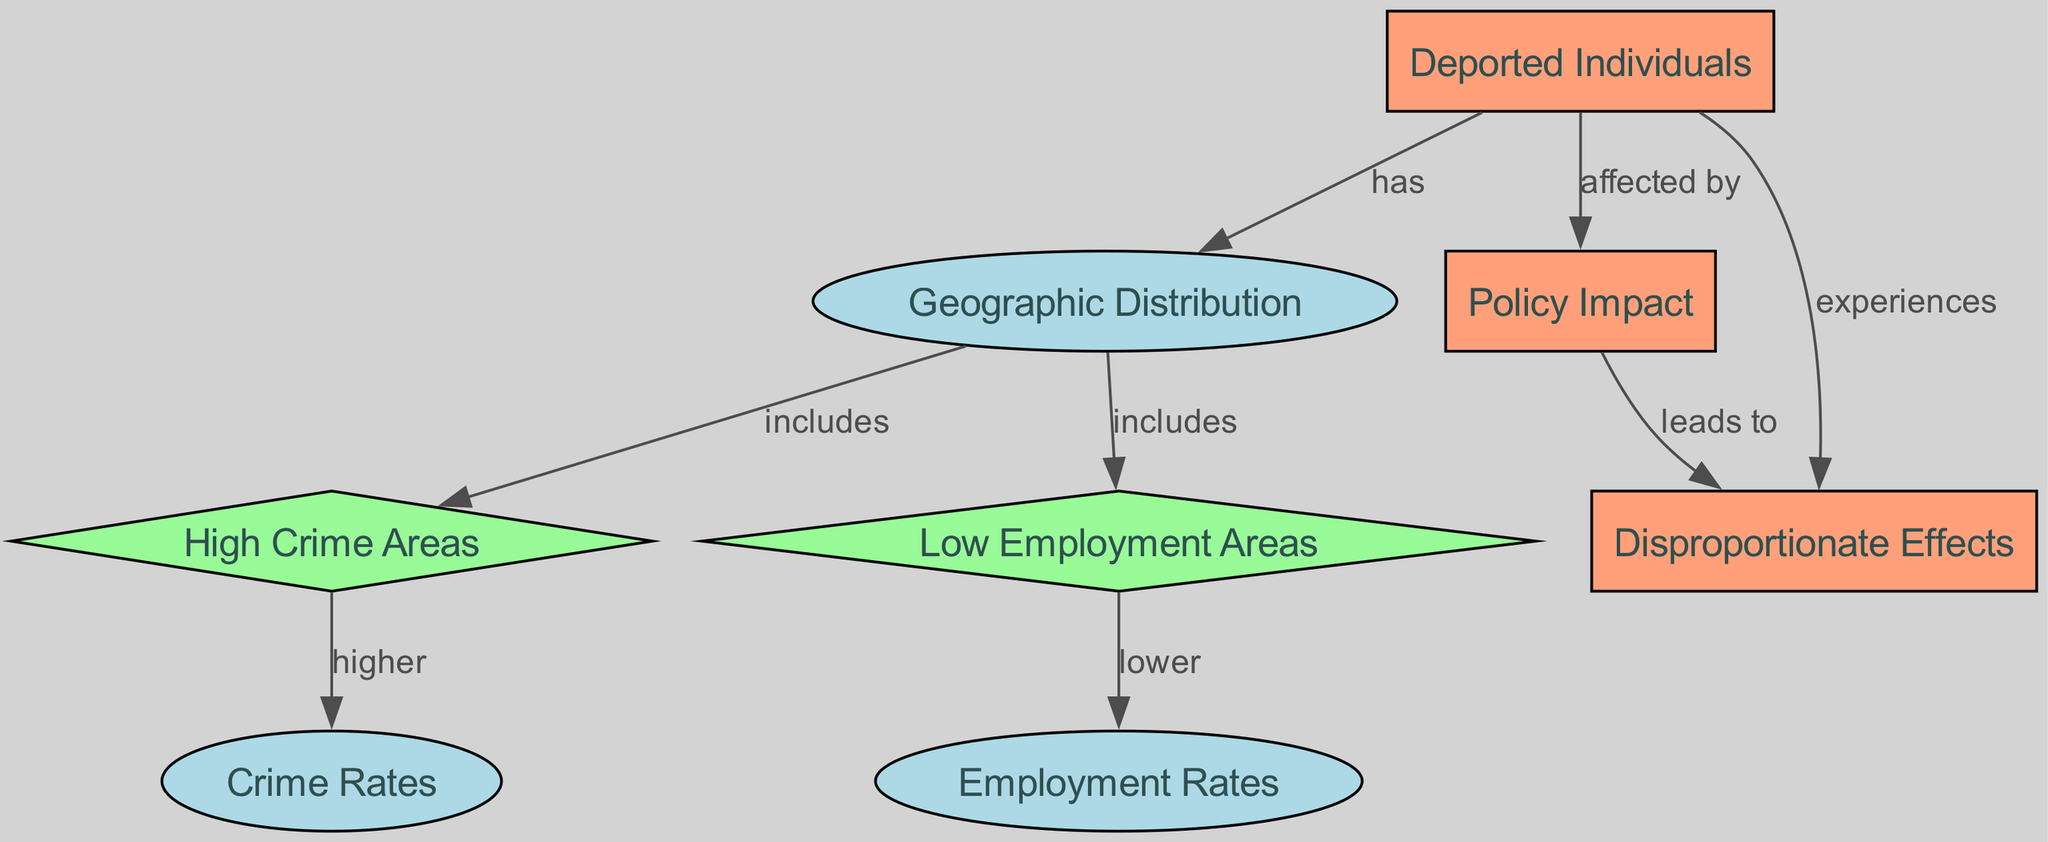What are the key components in the diagram? The diagram includes nodes for Deported Individuals, Geographic Distribution, Crime Rates, Employment Rates, High Crime Areas, Low Employment Areas, Policy Impact, and Disproportionate Effects.
Answer: Deported Individuals, Geographic Distribution, Crime Rates, Employment Rates, High Crime Areas, Low Employment Areas, Policy Impact, Disproportionate Effects How many edges are in the diagram? The diagram has 8 edges connecting various nodes, illustrating the relationships between them.
Answer: 8 What does 'Geographic Distribution' include? The 'Geographic Distribution' node includes two child nodes: High Crime Areas and Low Employment Areas, indicating regions where these issues are prevalent.
Answer: High Crime Areas, Low Employment Areas What relationship does 'High Crime Areas' have with 'Crime Rates'? 'High Crime Areas' has a direct relationship with 'Crime Rates', indicating that these areas experience higher crime rates, as specified by the directional edge.
Answer: Higher Which areas have lower employment rates? 'Low Employment Areas' is directly connected to the Employment Rates node, suggesting that these areas are characterized by lower employment rates.
Answer: Low Employment Areas What leads to disproportionate effects? The Policy Impact node connects with the Disproportionate Effects node, signifying that the impact of policies is what leads to these disproportionate effects on populations.
Answer: Policy Impact How does 'Deported Individuals' relate to 'Disproportionate Effects'? The 'Deported Individuals' node has a direct relationship with the 'Disproportionate Effects', meaning these individuals experience such effects due to immigration policies and their enforcement.
Answer: Experiences What kind of areas does 'Geographic Distribution' refer to? The 'Geographic Distribution' encompasses areas that are typically identified as either high crime or low employment, highlighting the socio-economic conditions tied to deportation policies.
Answer: High Crime Areas, Low Employment Areas How many types of nodes are depicted in the diagram? There are three distinct types of nodes: boxes for primary issues, ellipses for geographic and socio-economic factors, and diamonds that indicate areas of concern or impact.
Answer: 3 types 